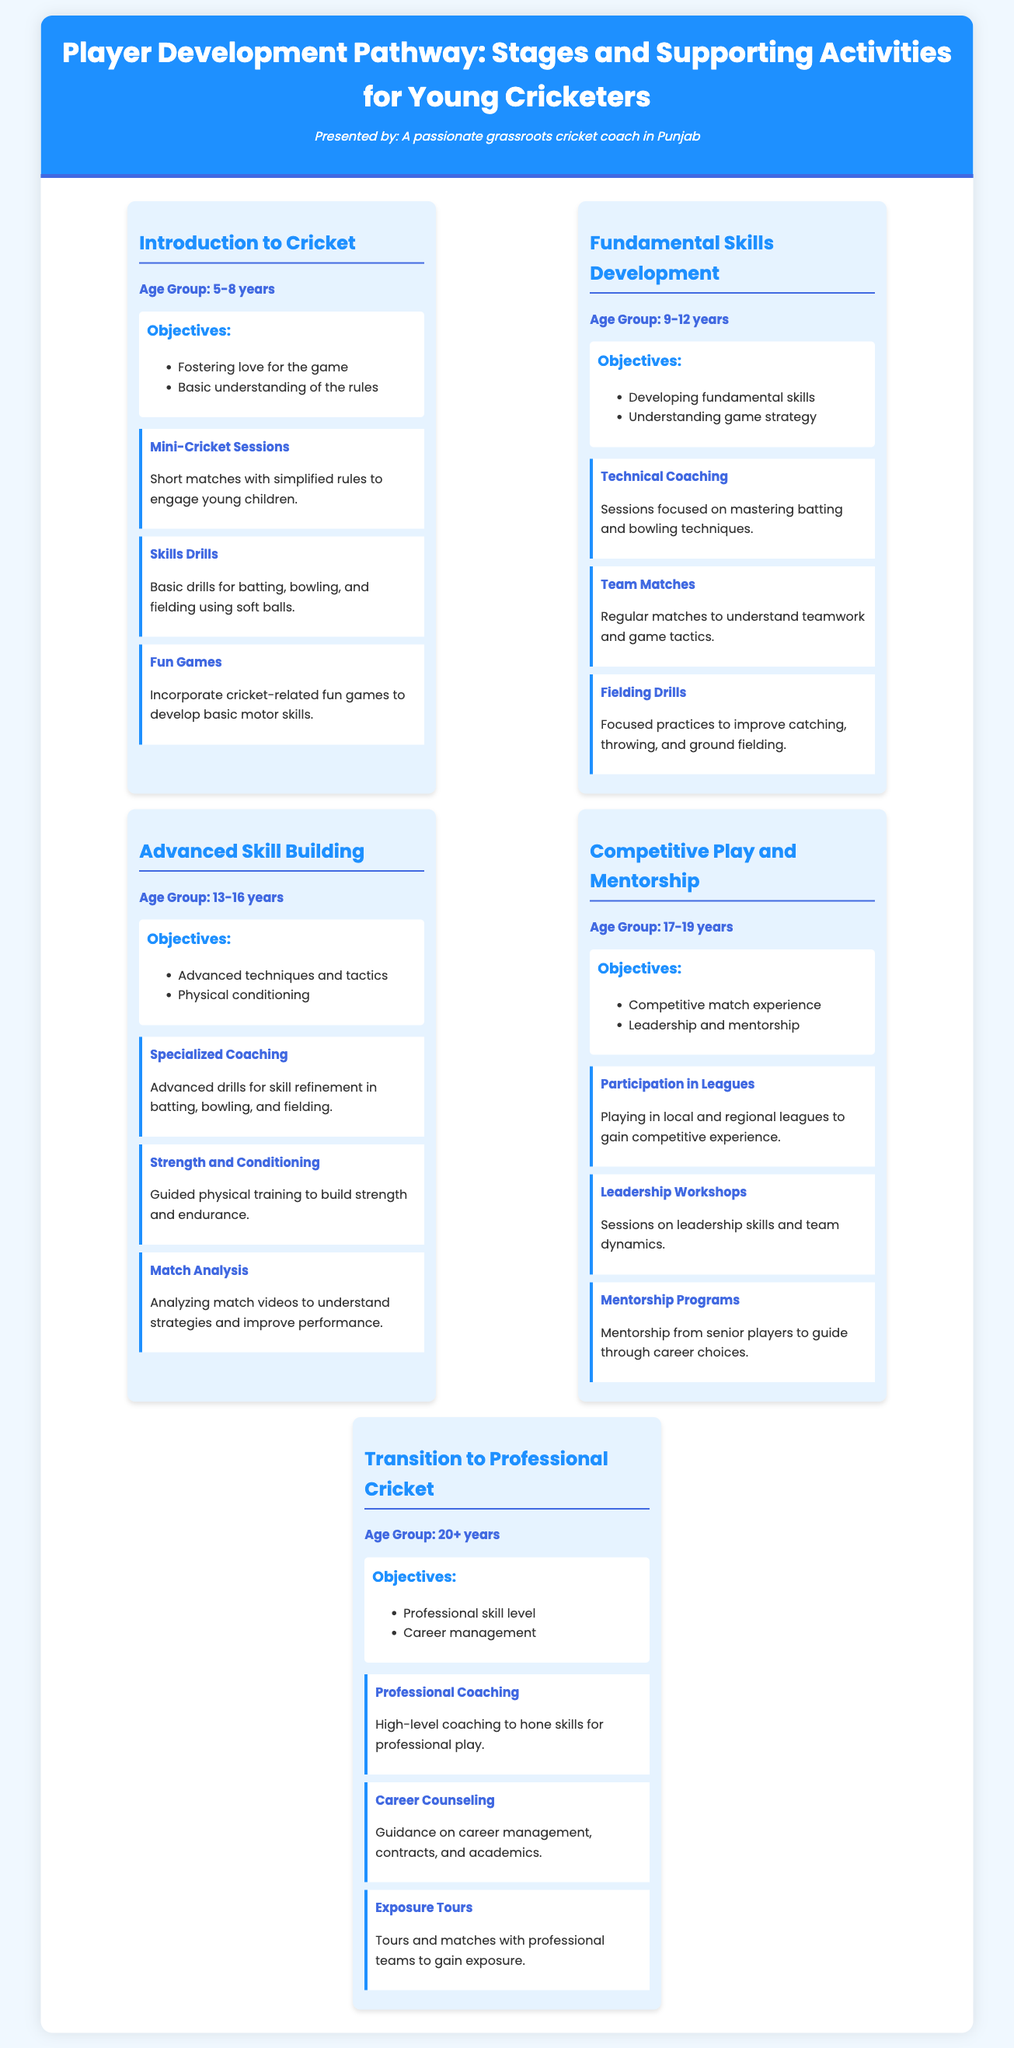What is the age group for "Introduction to Cricket"? The "Introduction to Cricket" stage is aimed at young cricketers aged 5-8 years.
Answer: 5-8 years What is one objective of the "Advanced Skill Building" stage? One objective of the "Advanced Skill Building" stage is to focus on advanced techniques and tactics.
Answer: Advanced techniques and tactics How many activities are listed under "Fundamental Skills Development"? There are three activities listed under the "Fundamental Skills Development" stage.
Answer: 3 What type of sessions are included in the "Competitive Play and Mentorship" stage? The "Competitive Play and Mentorship" stage includes sessions focused on leadership skills and team dynamics.
Answer: Leadership Workshops What is one activity listed in the "Transition to Professional Cricket" stage? One activity listed is "Professional Coaching" aimed at honing skills for professional play.
Answer: Professional Coaching Which age group is the focus of "Strength and Conditioning"? "Strength and Conditioning" activities are targeted at cricketers aged 13-16 years.
Answer: 13-16 years What overall goal does the "Introduction to Cricket" stage aim to achieve? The overall goal is to foster a love for the game and a basic understanding of the rules.
Answer: Fostering love for the game What is emphasized in the "Participation in Leagues" activity? The "Participation in Leagues" activity emphasizes gaining competitive experience through local and regional leagues.
Answer: Competitive experience What does the "Career Counseling" activity focus on? The "Career Counseling" activity focuses on guidance regarding career management and contracts.
Answer: Career management 